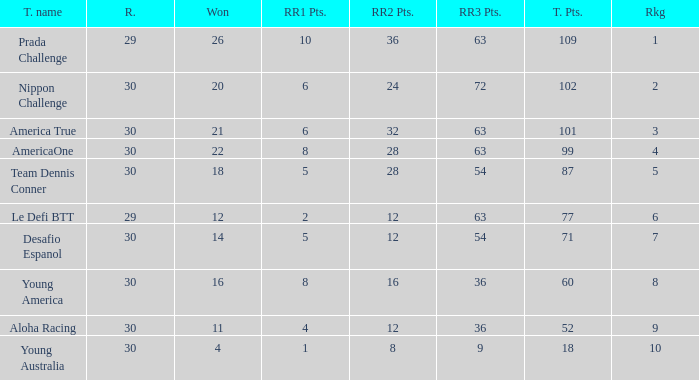Name the min total pts for team dennis conner 87.0. 